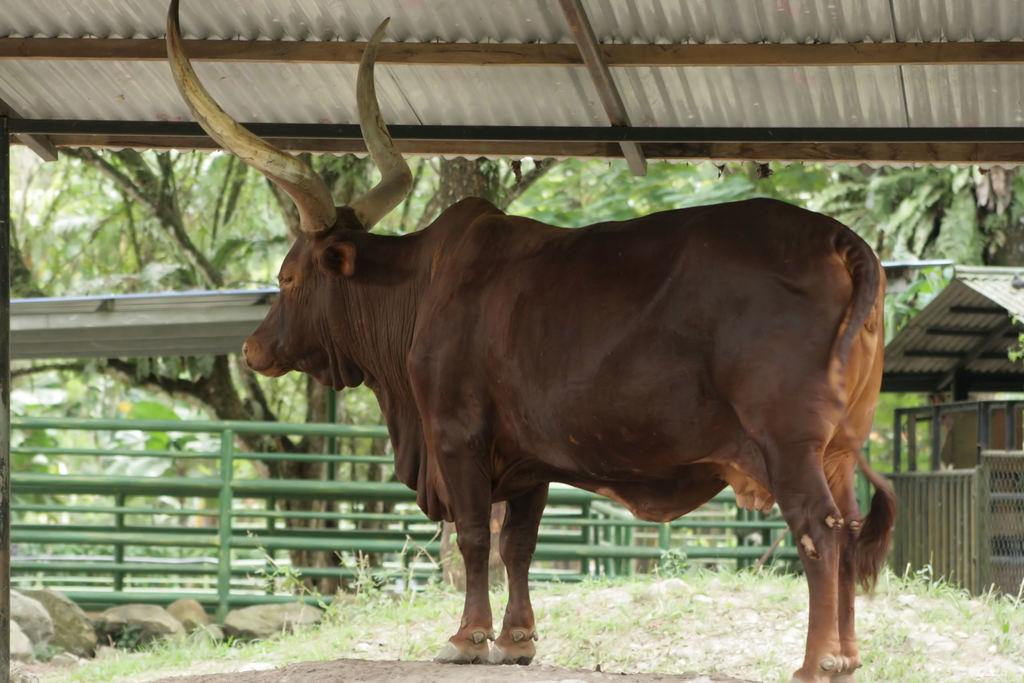What is inside the shed in the image? There is an animal in the shed. What type of vegetation can be seen on the path? Some grass is visible on the path. What can be found on the left side of the image? There are stones on the left side. What is visible in the distance behind the shed? Few trees are visible in the background. What type of brass instrument is being played by the animal in the shed? There is no brass instrument present in the image, and the animal is not playing any instrument. 